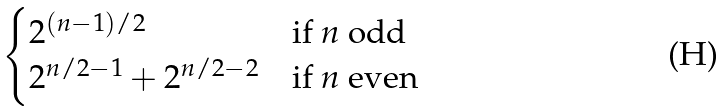Convert formula to latex. <formula><loc_0><loc_0><loc_500><loc_500>\begin{cases} 2 ^ { ( n - 1 ) / 2 } & \text {if $n$ odd} \\ 2 ^ { n / 2 - 1 } + 2 ^ { n / 2 - 2 } & \text {if $n$ even} \end{cases}</formula> 